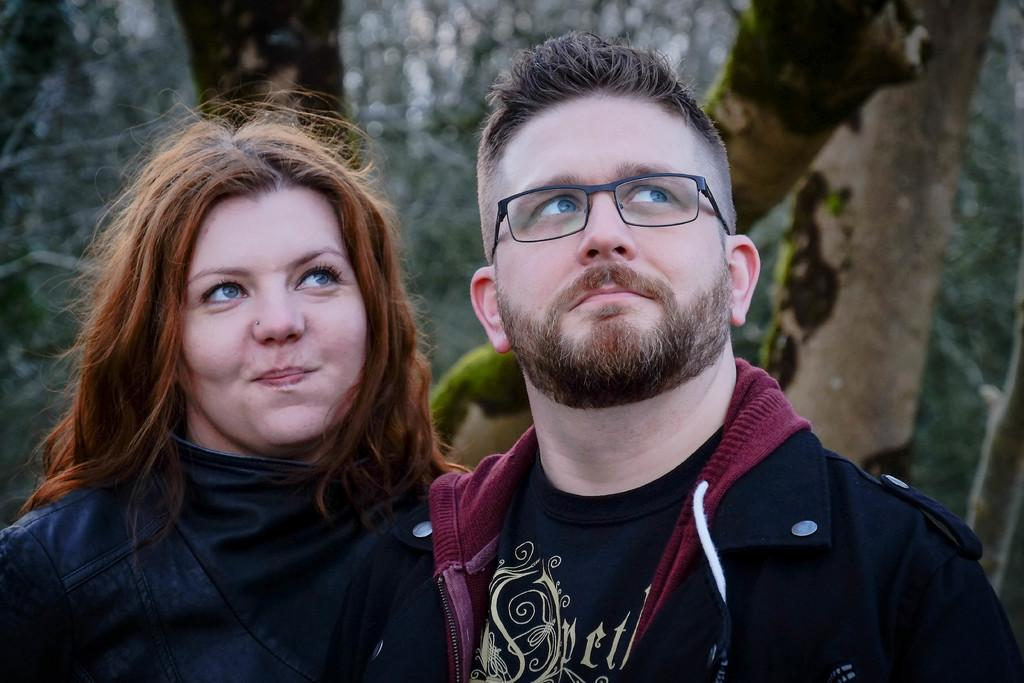How many people are in the image? There are two persons standing in the image. What is the man wearing? The man is wearing a black jacket. How is the woman positioned in relation to the man? The woman is standing beside the man. What is the woman's facial expression? The woman is smiling. What can be seen in the background of the image? There are trees visible in the background of the image. How would you describe the background's appearance? The background appears blurry. Can you hear the woman whistling in the image? There is no sound in the image, so it is not possible to hear the woman whistling. 